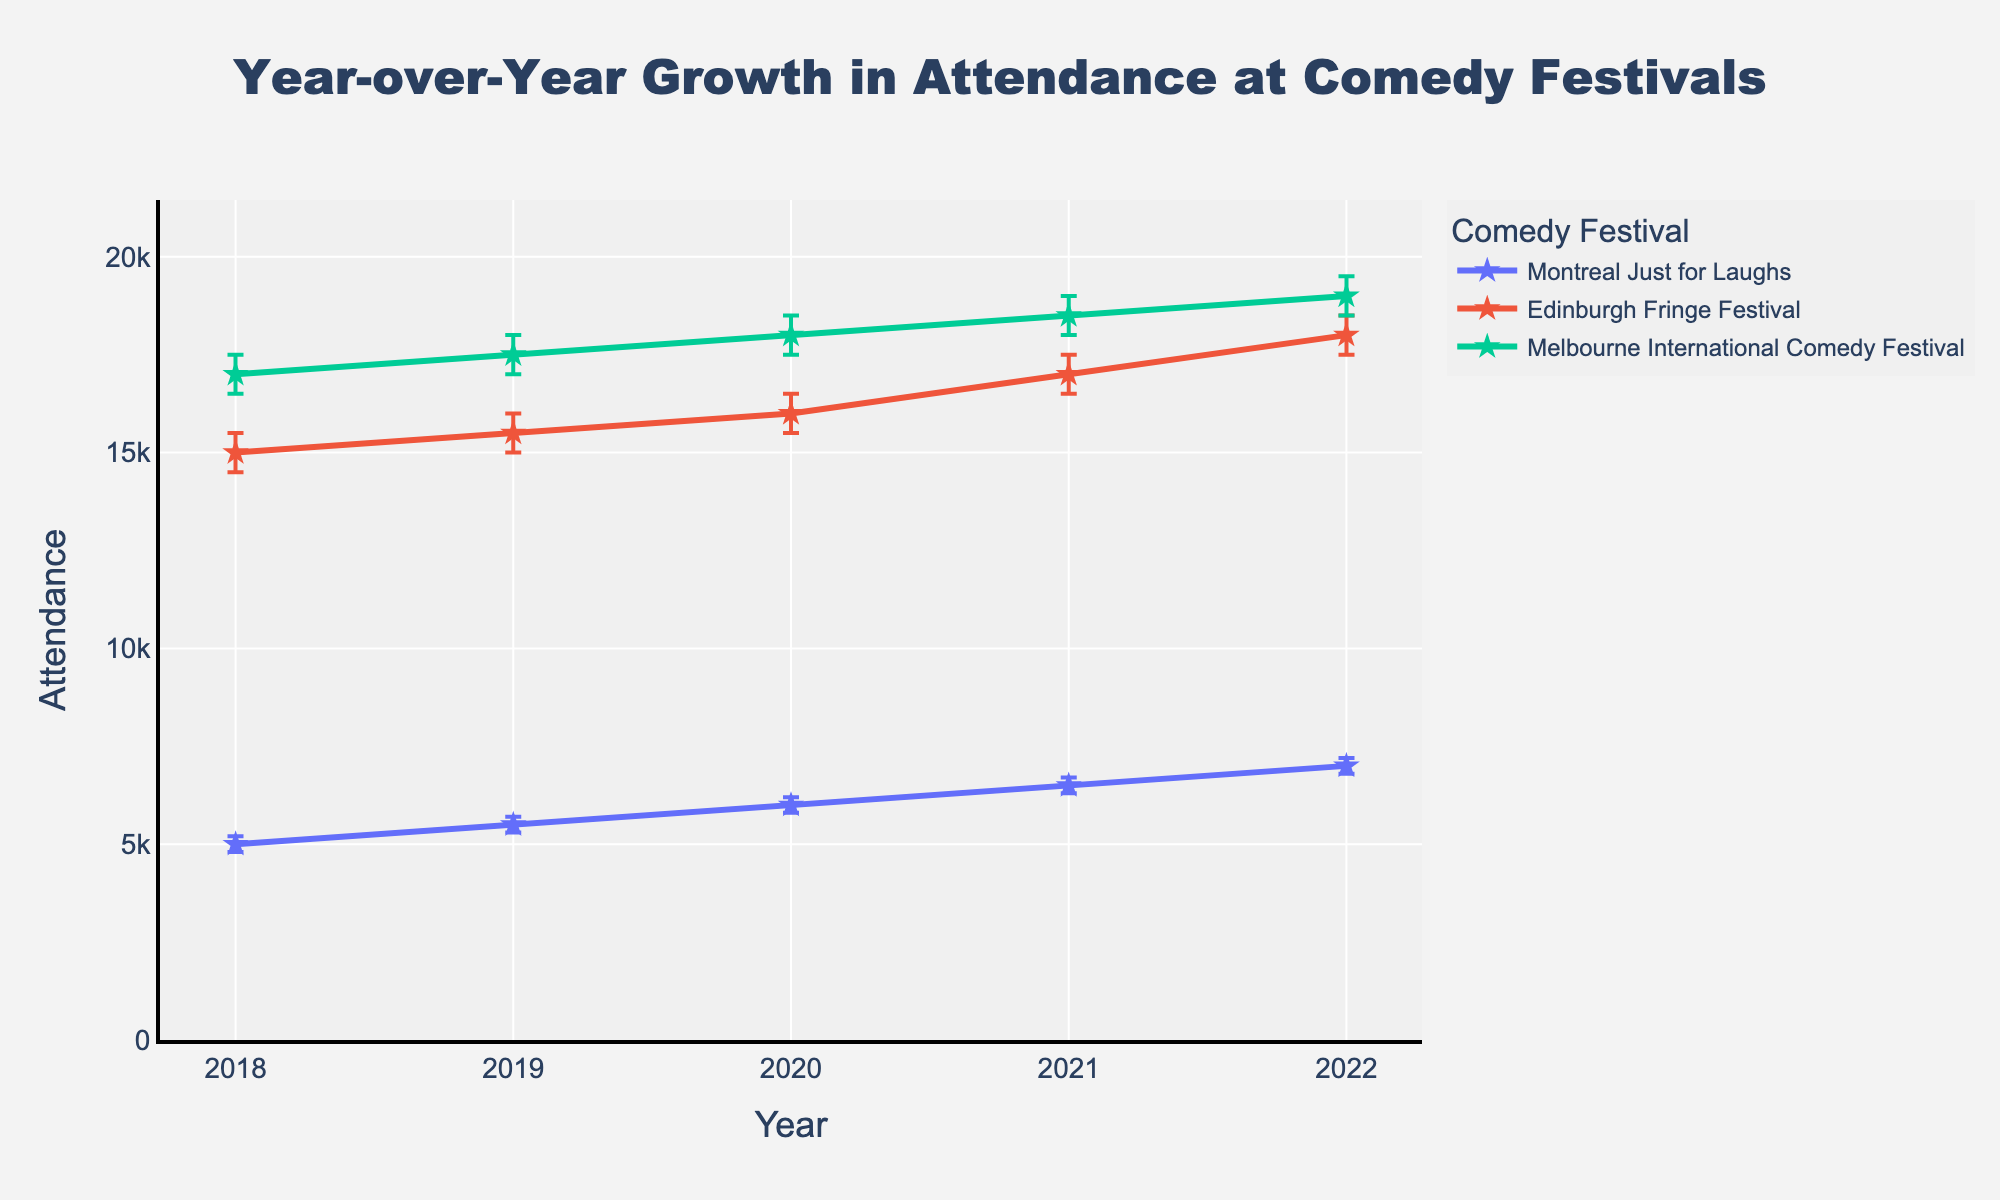Which comedy festival had the highest attendance in 2022? By comparing the final attendance levels on the plot for 2022, we can see that the Melbourne International Comedy Festival had the highest attendance among the three festivals.
Answer: Melbourne International Comedy Festival What is the title of the figure? The title is positioned at the top center of the plot and reads "Year-over-Year Growth in Attendance at Comedy Festivals".
Answer: Year-over-Year Growth in Attendance at Comedy Festivals Between 2018 and 2022, which festival showed the most consistent growth in attendance? Examining the plots for all three festivals, we observe that all lines show an upward trend, but the Montreal Just for Laughs festival has a steady increase in attendance each year with consistently increasing confidence intervals.
Answer: Montreal Just for Laughs What was the approximate increase in attendance for the Edinburgh Fringe Festival from 2019 to 2021? The attendance in 2019 was 15,500, and in 2021 it was 17,000. To find the increase: 17,000 - 15,500 = 1,500.
Answer: 1,500 Which comedy festival had the lowest attendance in 2018? By looking at the starting points for 2018 on the plot, the Montreal Just for Laughs festival had the lowest attendance at 5,000.
Answer: Montreal Just for Laughs In 2020, what is the difference between the upper confidence interval and the lower confidence interval for the Melbourne International Comedy Festival? The upper CI for 2020 is 18,500 and the lower CI is 17,500. The difference is 18,500 - 17,500 = 1,000.
Answer: 1,000 What does the Y-axis represent? The Y-axis is labeled "Attendance", indicating that it shows the number of attendees at the comedy festivals per year.
Answer: Attendance How does the growth trend for the Montreal Just for Laughs festival compare to the Melbourne International Comedy Festival between 2018 and 2022? Both show an upward trend, but the Montreal Just for Laughs festival shows smaller incremental changes and lower overall numbers compared to the Melbourne International Comedy Festival.
Answer: Both show upward trends; Montreal Just for Laughs has smaller increments What is the lowest value of the lower confidence interval for the Montreal Just for Laughs festival over all years? The plotting of confidence intervals reveals that the lowest value for the lower CI of Montreal Just for Laughs is 4,800 in 2018.
Answer: 4,800 Which festival’s attendance grew by exactly 1,000 between consecutive years, and in which years did this growth occur? By observing the plot, the Melbourne International Comedy Festival's attendance grew by 1,000 between each year from 2018 to 2022. This steady increment occurs consecutively every year.
Answer: Melbourne International Comedy Festival, 2018-2022 